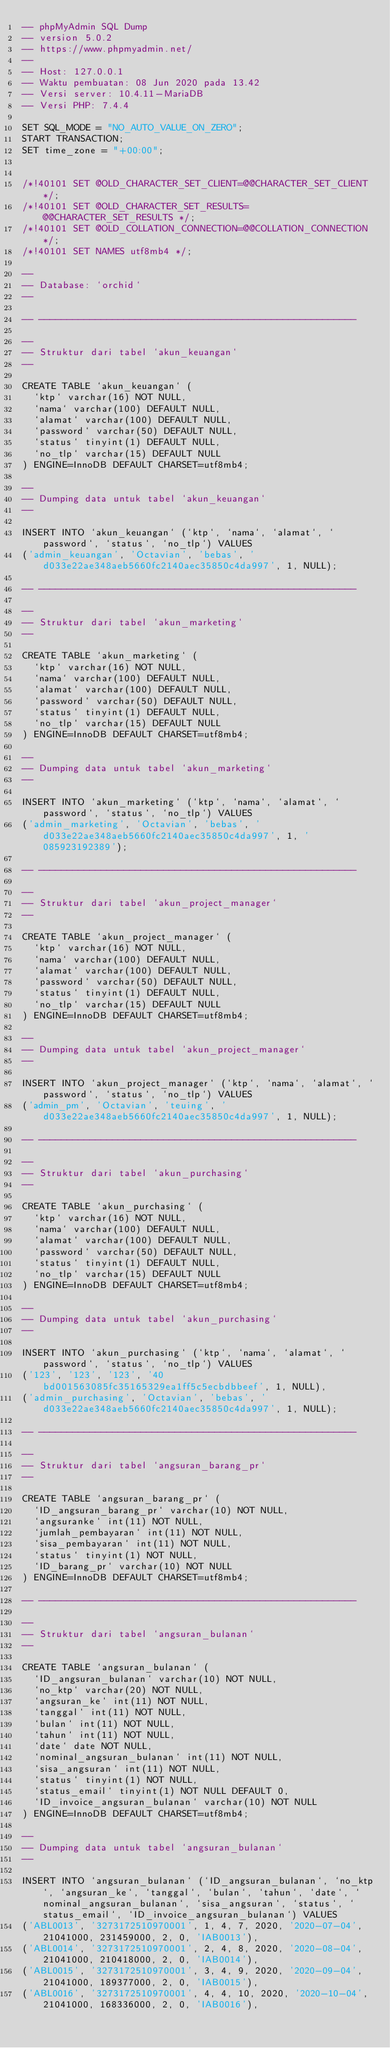<code> <loc_0><loc_0><loc_500><loc_500><_SQL_>-- phpMyAdmin SQL Dump
-- version 5.0.2
-- https://www.phpmyadmin.net/
--
-- Host: 127.0.0.1
-- Waktu pembuatan: 08 Jun 2020 pada 13.42
-- Versi server: 10.4.11-MariaDB
-- Versi PHP: 7.4.4

SET SQL_MODE = "NO_AUTO_VALUE_ON_ZERO";
START TRANSACTION;
SET time_zone = "+00:00";


/*!40101 SET @OLD_CHARACTER_SET_CLIENT=@@CHARACTER_SET_CLIENT */;
/*!40101 SET @OLD_CHARACTER_SET_RESULTS=@@CHARACTER_SET_RESULTS */;
/*!40101 SET @OLD_COLLATION_CONNECTION=@@COLLATION_CONNECTION */;
/*!40101 SET NAMES utf8mb4 */;

--
-- Database: `orchid`
--

-- --------------------------------------------------------

--
-- Struktur dari tabel `akun_keuangan`
--

CREATE TABLE `akun_keuangan` (
  `ktp` varchar(16) NOT NULL,
  `nama` varchar(100) DEFAULT NULL,
  `alamat` varchar(100) DEFAULT NULL,
  `password` varchar(50) DEFAULT NULL,
  `status` tinyint(1) DEFAULT NULL,
  `no_tlp` varchar(15) DEFAULT NULL
) ENGINE=InnoDB DEFAULT CHARSET=utf8mb4;

--
-- Dumping data untuk tabel `akun_keuangan`
--

INSERT INTO `akun_keuangan` (`ktp`, `nama`, `alamat`, `password`, `status`, `no_tlp`) VALUES
('admin_keuangan', 'Octavian', 'bebas', 'd033e22ae348aeb5660fc2140aec35850c4da997', 1, NULL);

-- --------------------------------------------------------

--
-- Struktur dari tabel `akun_marketing`
--

CREATE TABLE `akun_marketing` (
  `ktp` varchar(16) NOT NULL,
  `nama` varchar(100) DEFAULT NULL,
  `alamat` varchar(100) DEFAULT NULL,
  `password` varchar(50) DEFAULT NULL,
  `status` tinyint(1) DEFAULT NULL,
  `no_tlp` varchar(15) DEFAULT NULL
) ENGINE=InnoDB DEFAULT CHARSET=utf8mb4;

--
-- Dumping data untuk tabel `akun_marketing`
--

INSERT INTO `akun_marketing` (`ktp`, `nama`, `alamat`, `password`, `status`, `no_tlp`) VALUES
('admin_marketing', 'Octavian', 'bebas', 'd033e22ae348aeb5660fc2140aec35850c4da997', 1, '085923192389');

-- --------------------------------------------------------

--
-- Struktur dari tabel `akun_project_manager`
--

CREATE TABLE `akun_project_manager` (
  `ktp` varchar(16) NOT NULL,
  `nama` varchar(100) DEFAULT NULL,
  `alamat` varchar(100) DEFAULT NULL,
  `password` varchar(50) DEFAULT NULL,
  `status` tinyint(1) DEFAULT NULL,
  `no_tlp` varchar(15) DEFAULT NULL
) ENGINE=InnoDB DEFAULT CHARSET=utf8mb4;

--
-- Dumping data untuk tabel `akun_project_manager`
--

INSERT INTO `akun_project_manager` (`ktp`, `nama`, `alamat`, `password`, `status`, `no_tlp`) VALUES
('admin_pm', 'Octavian', 'teuing', 'd033e22ae348aeb5660fc2140aec35850c4da997', 1, NULL);

-- --------------------------------------------------------

--
-- Struktur dari tabel `akun_purchasing`
--

CREATE TABLE `akun_purchasing` (
  `ktp` varchar(16) NOT NULL,
  `nama` varchar(100) DEFAULT NULL,
  `alamat` varchar(100) DEFAULT NULL,
  `password` varchar(50) DEFAULT NULL,
  `status` tinyint(1) DEFAULT NULL,
  `no_tlp` varchar(15) DEFAULT NULL
) ENGINE=InnoDB DEFAULT CHARSET=utf8mb4;

--
-- Dumping data untuk tabel `akun_purchasing`
--

INSERT INTO `akun_purchasing` (`ktp`, `nama`, `alamat`, `password`, `status`, `no_tlp`) VALUES
('123', '123', '123', '40bd001563085fc35165329ea1ff5c5ecbdbbeef', 1, NULL),
('admin_purchasing', 'Octavian', 'bebas', 'd033e22ae348aeb5660fc2140aec35850c4da997', 1, NULL);

-- --------------------------------------------------------

--
-- Struktur dari tabel `angsuran_barang_pr`
--

CREATE TABLE `angsuran_barang_pr` (
  `ID_angsuran_barang_pr` varchar(10) NOT NULL,
  `angsuranke` int(11) NOT NULL,
  `jumlah_pembayaran` int(11) NOT NULL,
  `sisa_pembayaran` int(11) NOT NULL,
  `status` tinyint(1) NOT NULL,
  `ID_barang_pr` varchar(10) NOT NULL
) ENGINE=InnoDB DEFAULT CHARSET=utf8mb4;

-- --------------------------------------------------------

--
-- Struktur dari tabel `angsuran_bulanan`
--

CREATE TABLE `angsuran_bulanan` (
  `ID_angsuran_bulanan` varchar(10) NOT NULL,
  `no_ktp` varchar(20) NOT NULL,
  `angsuran_ke` int(11) NOT NULL,
  `tanggal` int(11) NOT NULL,
  `bulan` int(11) NOT NULL,
  `tahun` int(11) NOT NULL,
  `date` date NOT NULL,
  `nominal_angsuran_bulanan` int(11) NOT NULL,
  `sisa_angsuran` int(11) NOT NULL,
  `status` tinyint(1) NOT NULL,
  `status_email` tinyint(1) NOT NULL DEFAULT 0,
  `ID_invoice_angsuran_bulanan` varchar(10) NOT NULL
) ENGINE=InnoDB DEFAULT CHARSET=utf8mb4;

--
-- Dumping data untuk tabel `angsuran_bulanan`
--

INSERT INTO `angsuran_bulanan` (`ID_angsuran_bulanan`, `no_ktp`, `angsuran_ke`, `tanggal`, `bulan`, `tahun`, `date`, `nominal_angsuran_bulanan`, `sisa_angsuran`, `status`, `status_email`, `ID_invoice_angsuran_bulanan`) VALUES
('ABL0013', '3273172510970001', 1, 4, 7, 2020, '2020-07-04', 21041000, 231459000, 2, 0, 'IAB0013'),
('ABL0014', '3273172510970001', 2, 4, 8, 2020, '2020-08-04', 21041000, 210418000, 2, 0, 'IAB0014'),
('ABL0015', '3273172510970001', 3, 4, 9, 2020, '2020-09-04', 21041000, 189377000, 2, 0, 'IAB0015'),
('ABL0016', '3273172510970001', 4, 4, 10, 2020, '2020-10-04', 21041000, 168336000, 2, 0, 'IAB0016'),</code> 